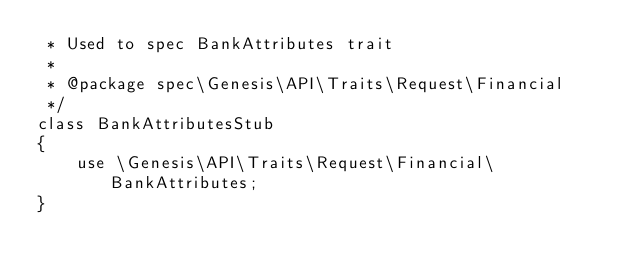<code> <loc_0><loc_0><loc_500><loc_500><_PHP_> * Used to spec BankAttributes trait
 *
 * @package spec\Genesis\API\Traits\Request\Financial
 */
class BankAttributesStub
{
    use \Genesis\API\Traits\Request\Financial\BankAttributes;
}
</code> 